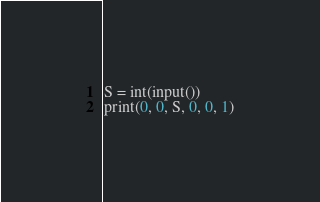Convert code to text. <code><loc_0><loc_0><loc_500><loc_500><_Python_>S = int(input())
print(0, 0, S, 0, 0, 1)
</code> 